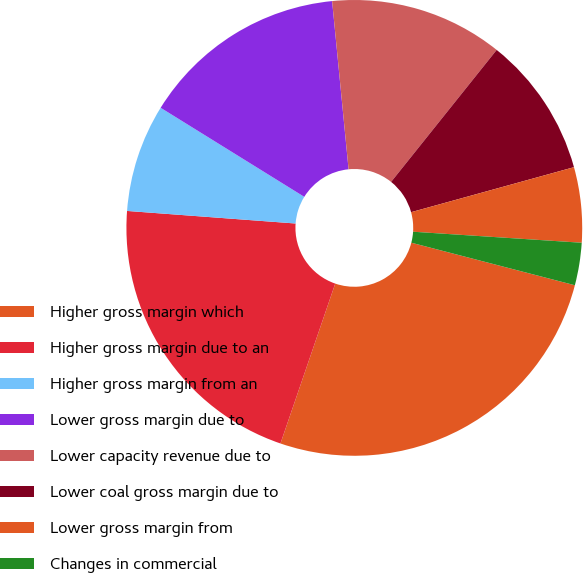<chart> <loc_0><loc_0><loc_500><loc_500><pie_chart><fcel>Higher gross margin which<fcel>Higher gross margin due to an<fcel>Higher gross margin from an<fcel>Lower gross margin due to<fcel>Lower capacity revenue due to<fcel>Lower coal gross margin due to<fcel>Lower gross margin from<fcel>Changes in commercial<nl><fcel>26.2%<fcel>20.93%<fcel>7.65%<fcel>14.61%<fcel>12.29%<fcel>9.97%<fcel>5.33%<fcel>3.01%<nl></chart> 